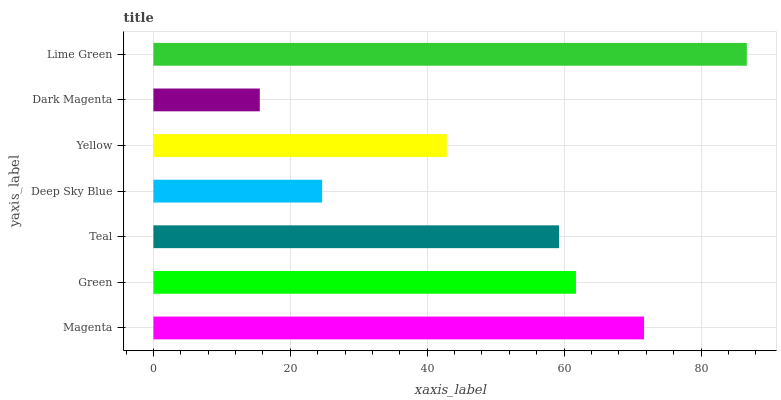Is Dark Magenta the minimum?
Answer yes or no. Yes. Is Lime Green the maximum?
Answer yes or no. Yes. Is Green the minimum?
Answer yes or no. No. Is Green the maximum?
Answer yes or no. No. Is Magenta greater than Green?
Answer yes or no. Yes. Is Green less than Magenta?
Answer yes or no. Yes. Is Green greater than Magenta?
Answer yes or no. No. Is Magenta less than Green?
Answer yes or no. No. Is Teal the high median?
Answer yes or no. Yes. Is Teal the low median?
Answer yes or no. Yes. Is Deep Sky Blue the high median?
Answer yes or no. No. Is Green the low median?
Answer yes or no. No. 